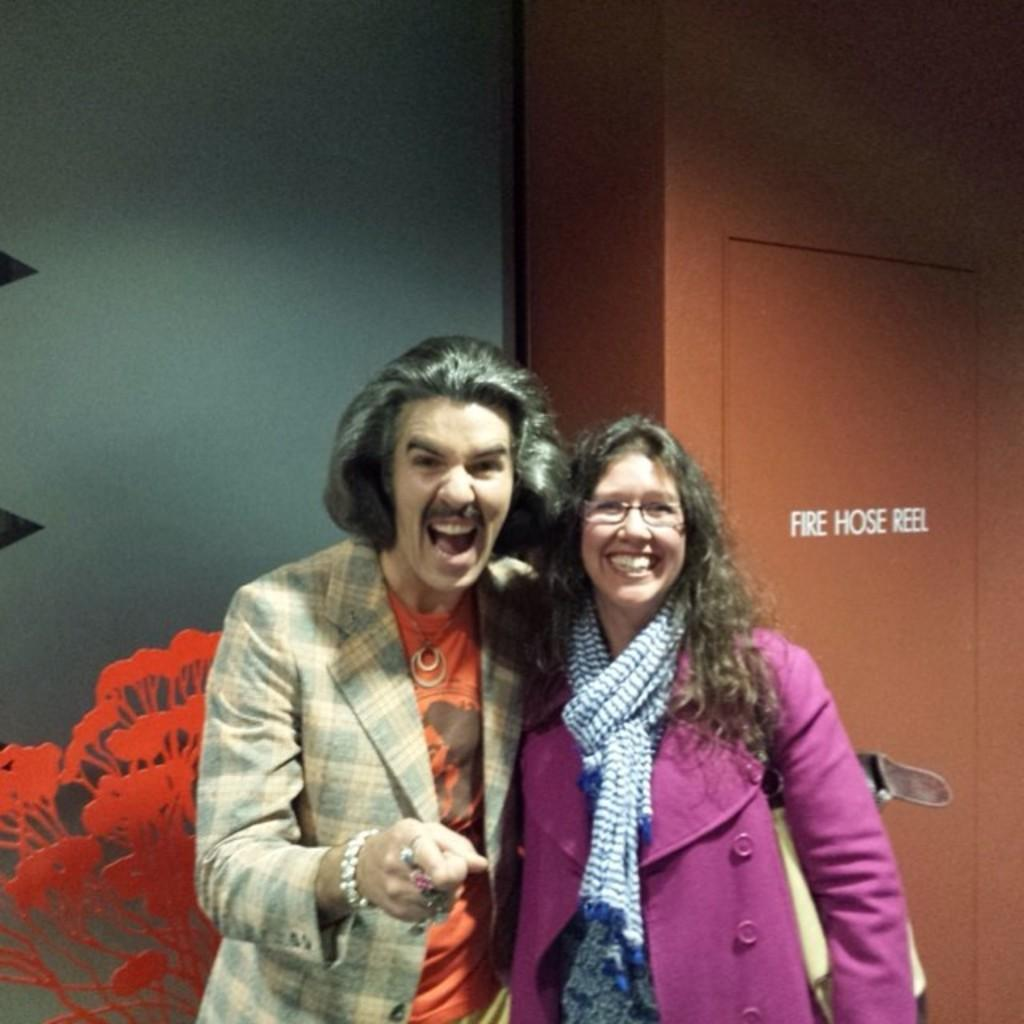Who are the people in the image? There is a man and a woman in the image. What are the expressions on their faces? Both the man and the woman are smiling in the image. Can you describe the woman's appearance? The woman is wearing spectacles in the image. What can be seen in the background of the image? There is a wall in the background of the image. What type of toothpaste is the man using in the image? There is no toothpaste present in the image, as it features a man and a woman smiling and does not show any toothpaste or brushing activity. 